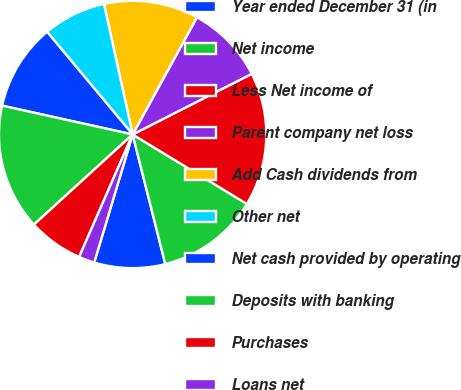<chart> <loc_0><loc_0><loc_500><loc_500><pie_chart><fcel>Year ended December 31 (in<fcel>Net income<fcel>Less Net income of<fcel>Parent company net loss<fcel>Add Cash dividends from<fcel>Other net<fcel>Net cash provided by operating<fcel>Deposits with banking<fcel>Purchases<fcel>Loans net<nl><fcel>8.57%<fcel>12.38%<fcel>16.19%<fcel>9.52%<fcel>11.43%<fcel>7.62%<fcel>10.48%<fcel>15.24%<fcel>6.67%<fcel>1.91%<nl></chart> 